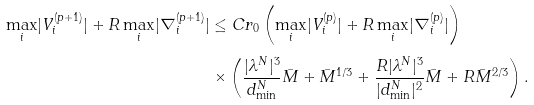Convert formula to latex. <formula><loc_0><loc_0><loc_500><loc_500>\underset { i } { \max } | V _ { i } ^ { ( p + 1 ) } | + R \, \underset { i } { \max } | \nabla _ { i } ^ { ( p + 1 ) } | & \leq C r _ { 0 } \left ( \underset { i } { \max } | V _ { i } ^ { ( p ) } | + R \, \underset { i } { \max } | \nabla _ { i } ^ { ( p ) } | \right ) \\ & \times \left ( \frac { | \lambda ^ { N } | ^ { 3 } } { d _ { \min } ^ { N } } \bar { M } + \bar { M } ^ { 1 / 3 } + \frac { R | \lambda ^ { N } | ^ { 3 } } { | d _ { \min } ^ { N } | ^ { 2 } } \bar { M } + R \bar { M } ^ { 2 / 3 } \right ) .</formula> 